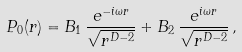<formula> <loc_0><loc_0><loc_500><loc_500>P _ { 0 } ( r ) = B _ { 1 } \, \frac { e ^ { - i \omega r } } { \sqrt { r ^ { D - 2 } } } + B _ { 2 } \, \frac { e ^ { i \omega r } } { \sqrt { r ^ { D - 2 } } } \, ,</formula> 